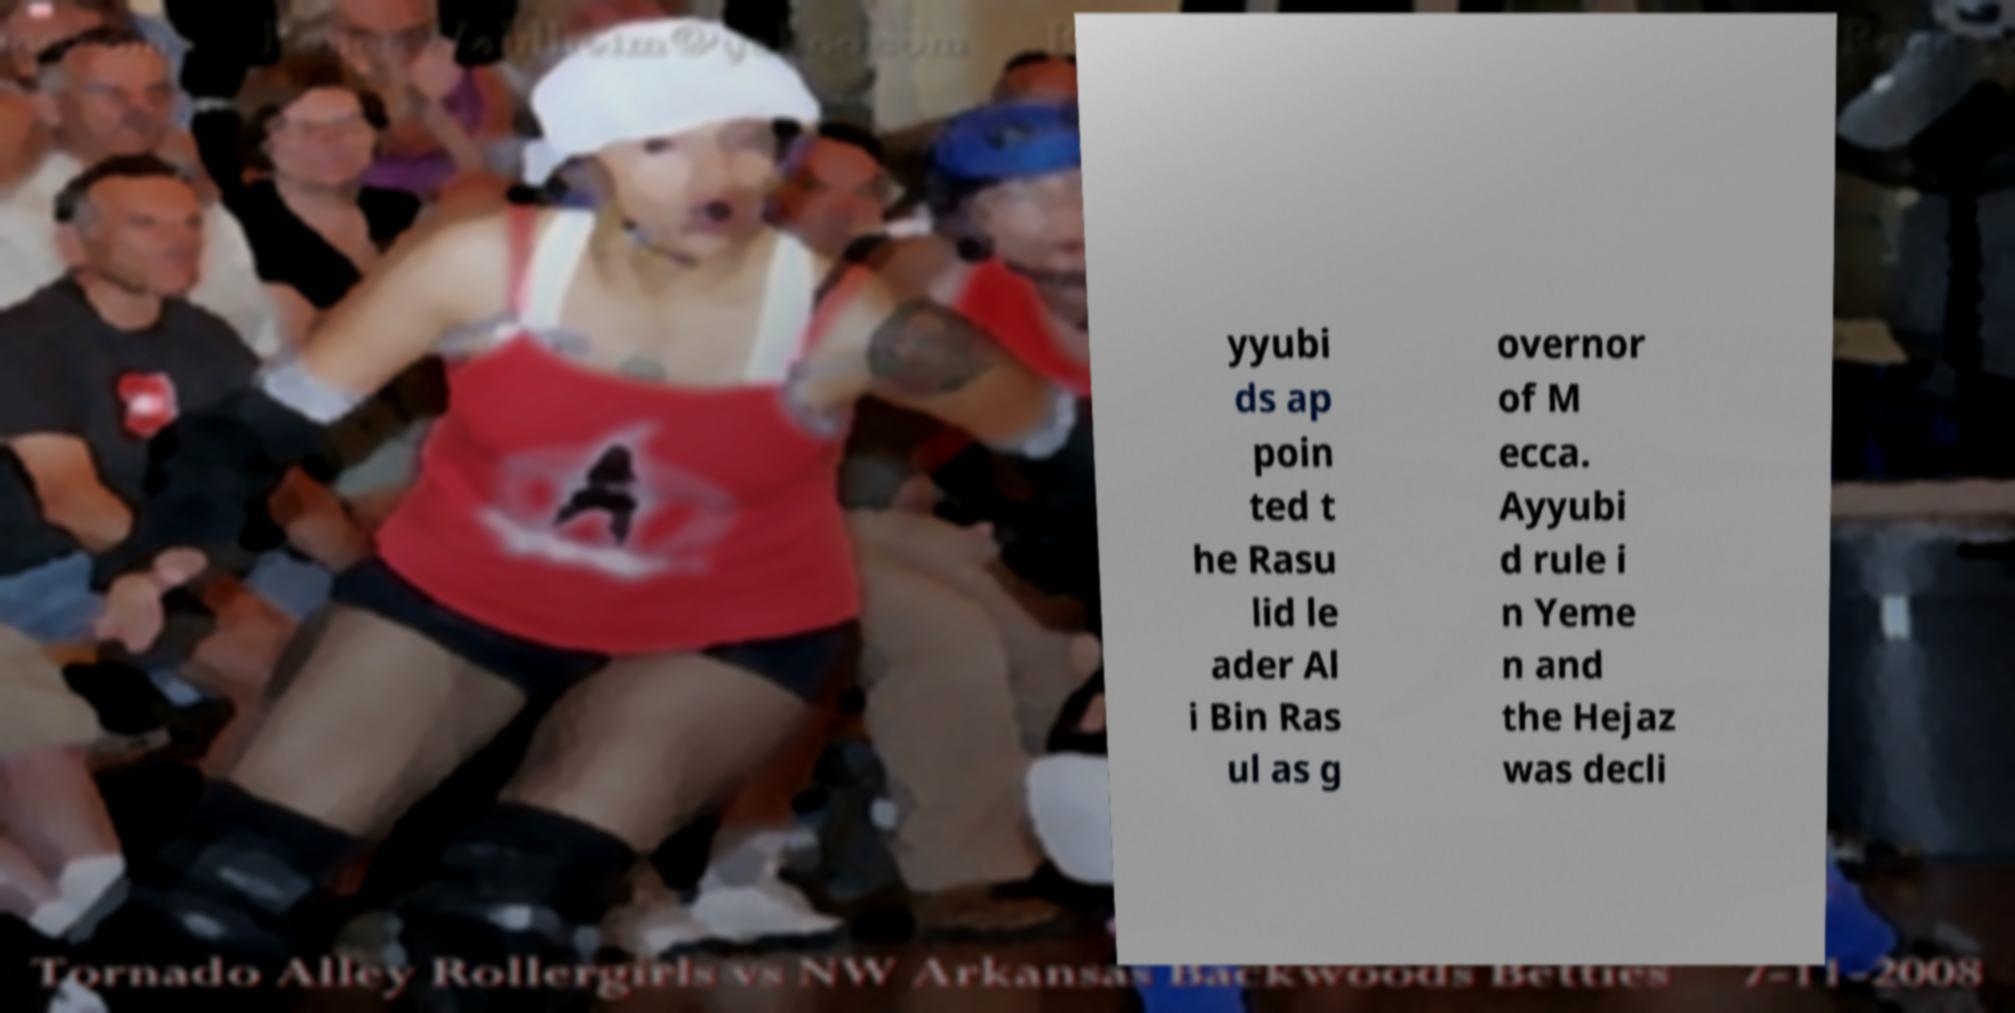I need the written content from this picture converted into text. Can you do that? yyubi ds ap poin ted t he Rasu lid le ader Al i Bin Ras ul as g overnor of M ecca. Ayyubi d rule i n Yeme n and the Hejaz was decli 